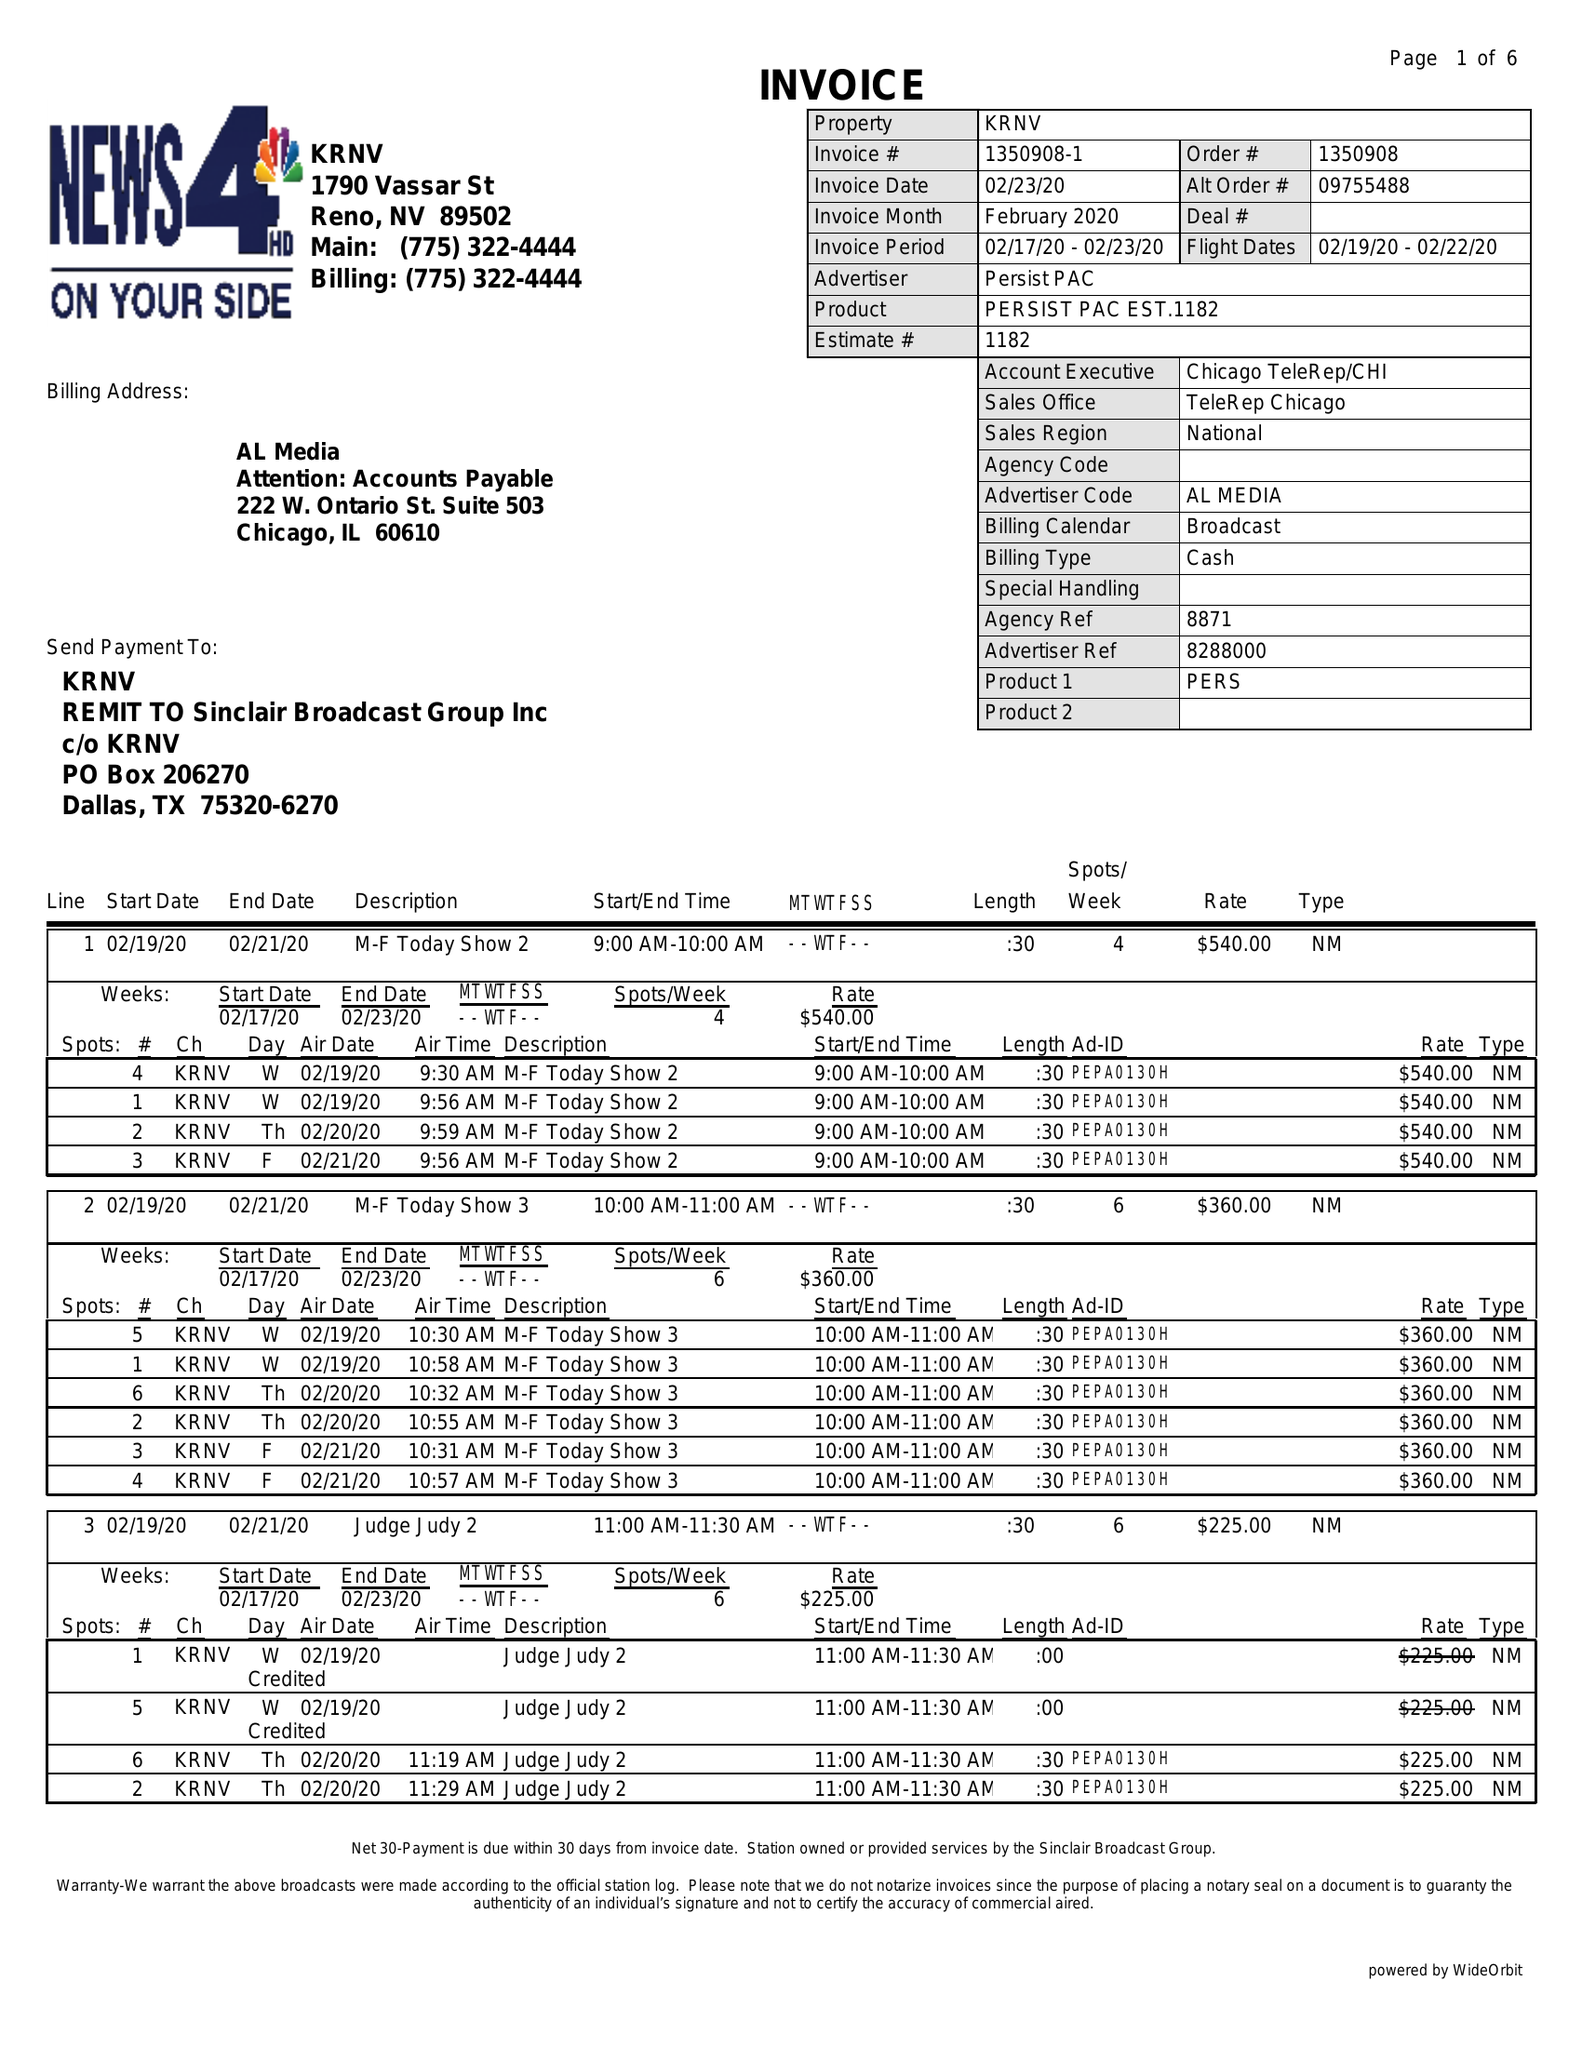What is the value for the gross_amount?
Answer the question using a single word or phrase. 57510.00 